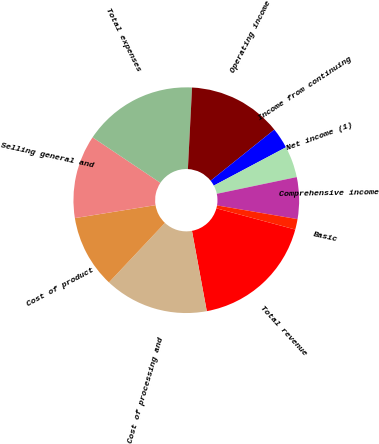<chart> <loc_0><loc_0><loc_500><loc_500><pie_chart><fcel>Total revenue<fcel>Cost of processing and<fcel>Cost of product<fcel>Selling general and<fcel>Total expenses<fcel>Operating income<fcel>Income from continuing<fcel>Net income (1)<fcel>Comprehensive income<fcel>Basic<nl><fcel>17.91%<fcel>14.92%<fcel>10.45%<fcel>11.94%<fcel>16.41%<fcel>13.43%<fcel>2.99%<fcel>4.48%<fcel>5.97%<fcel>1.5%<nl></chart> 